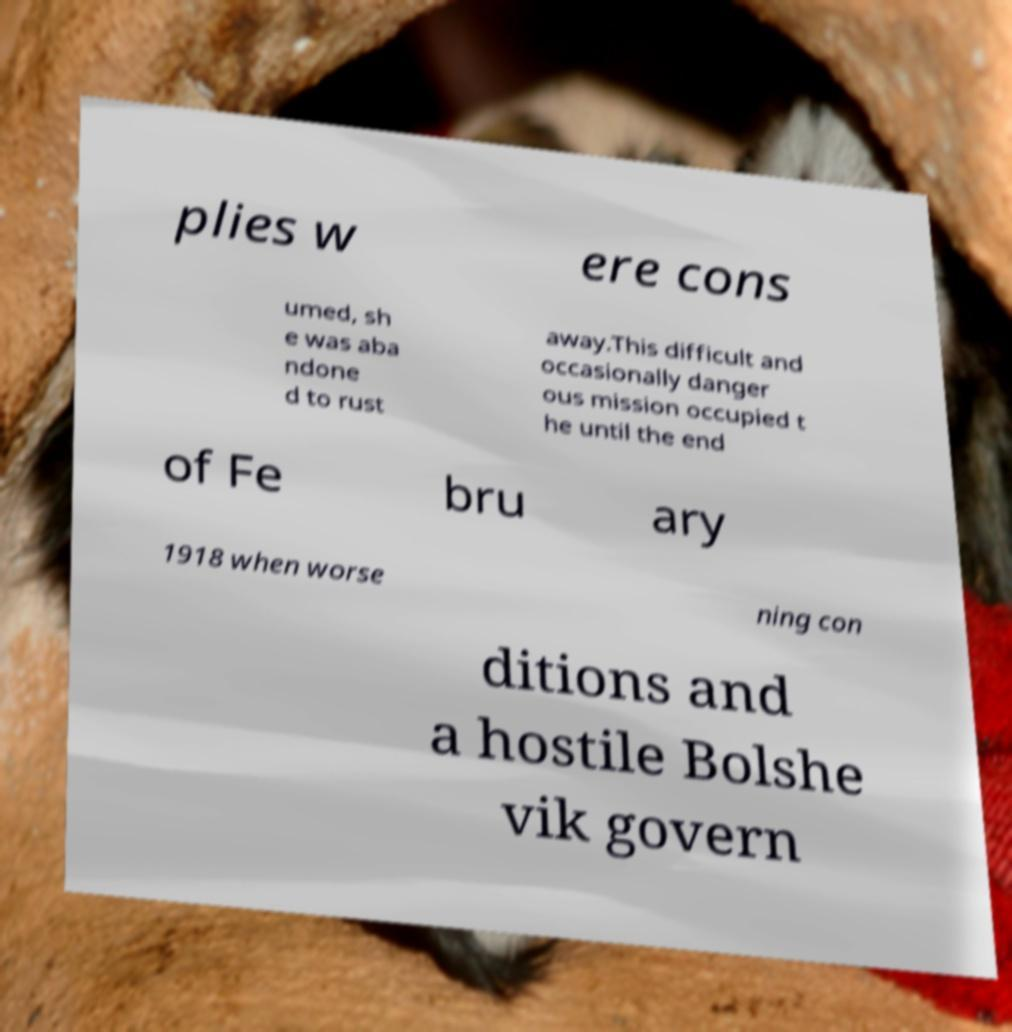Please read and relay the text visible in this image. What does it say? plies w ere cons umed, sh e was aba ndone d to rust away.This difficult and occasionally danger ous mission occupied t he until the end of Fe bru ary 1918 when worse ning con ditions and a hostile Bolshe vik govern 